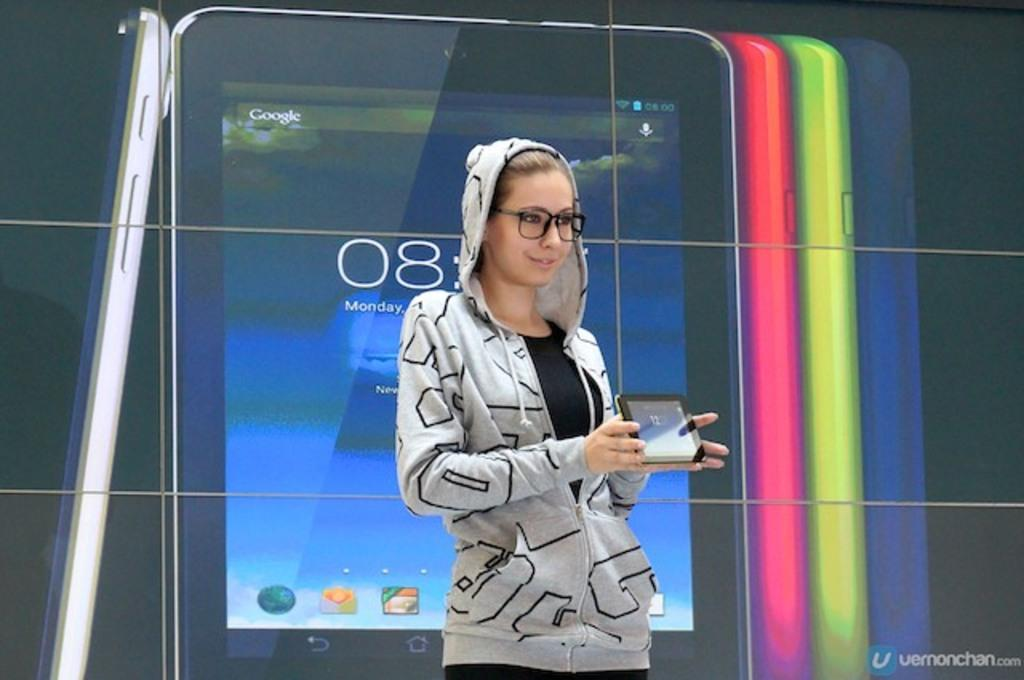Who is the main subject in the image? There is a woman in the image. What is the woman doing in the image? The woman is standing in the image. What is the woman wearing in the image? The woman is wearing clothes and spectacles in the image. What is the woman's facial expression in the image? The woman is smiling in the image. What is the woman holding in her hand in the image? The woman is holding an electronic device in her hand in the image. What can be seen on the screen of the electronic device? There is text visible on the screen of the electronic device in the image. What type of furniture is the woman sitting on in the image? There is no furniture present in the image, as the woman is standing. What is the woman eating for lunch in the image? There is no mention of lunch or food in the image. 